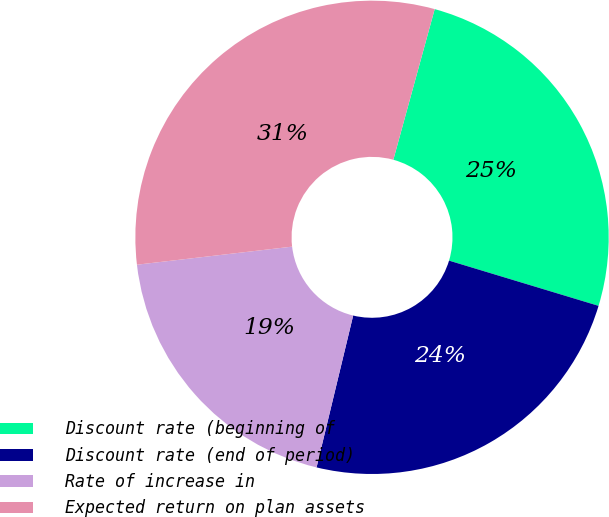Convert chart to OTSL. <chart><loc_0><loc_0><loc_500><loc_500><pie_chart><fcel>Discount rate (beginning of<fcel>Discount rate (end of period)<fcel>Rate of increase in<fcel>Expected return on plan assets<nl><fcel>25.41%<fcel>24.09%<fcel>19.39%<fcel>31.11%<nl></chart> 